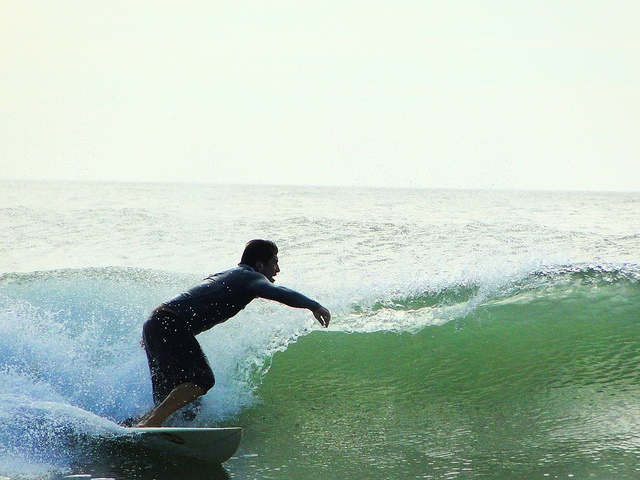Describe the objects in this image and their specific colors. I can see people in beige, black, gray, ivory, and navy tones and surfboard in beige, black, teal, and gray tones in this image. 